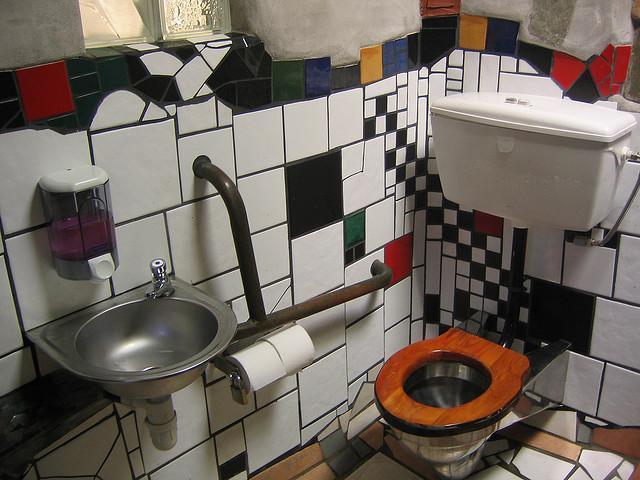How many rolls of toilet paper are there?
Give a very brief answer. 2. How many people are wearing helmet?
Give a very brief answer. 0. 